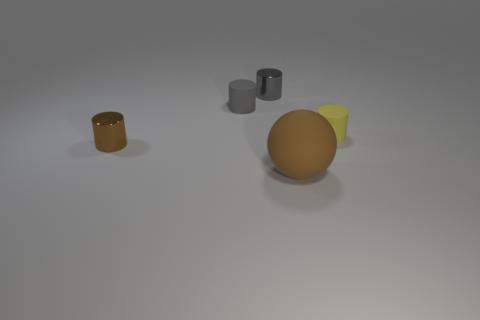Is there anything else that is the same size as the gray matte object? Considering the visible objects in the image, the two gray cylindrical objects appear to be very close in size to each other. If you are referring to the larger spherical object as the gray matte object, the yellow wedge-shaped object is not of the same size, whereas the smaller orange-brown container may have a similar height but different shape and volume. Therefore, there is at least one other object that matches the size of one of the gray cylindrical objects. 